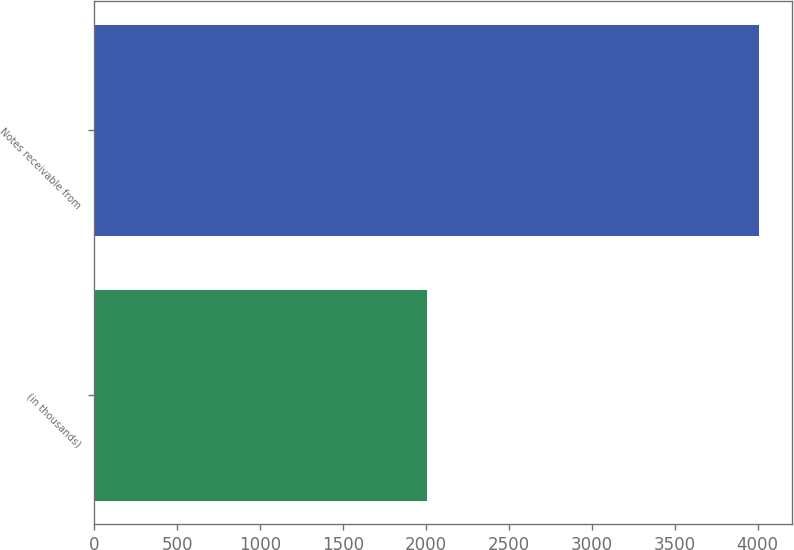Convert chart. <chart><loc_0><loc_0><loc_500><loc_500><bar_chart><fcel>(in thousands)<fcel>Notes receivable from<nl><fcel>2007<fcel>4006<nl></chart> 